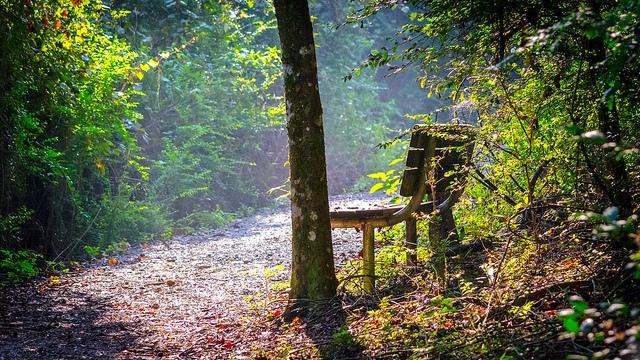What is the trail made out of?
Quick response, please. Dirt. Does this look like a busy place?
Write a very short answer. No. Is there somewhere to sit in this photo?
Answer briefly. Yes. 